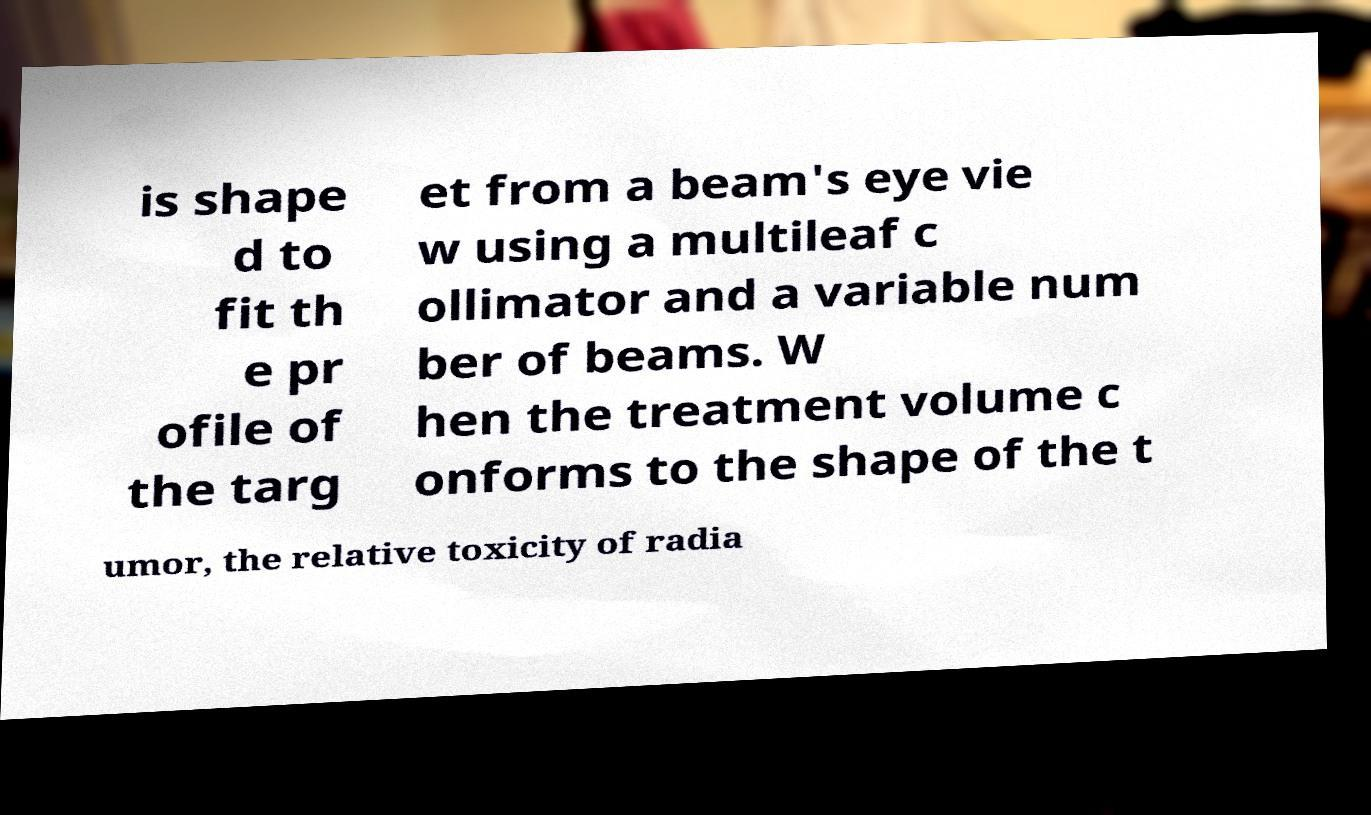Can you accurately transcribe the text from the provided image for me? is shape d to fit th e pr ofile of the targ et from a beam's eye vie w using a multileaf c ollimator and a variable num ber of beams. W hen the treatment volume c onforms to the shape of the t umor, the relative toxicity of radia 